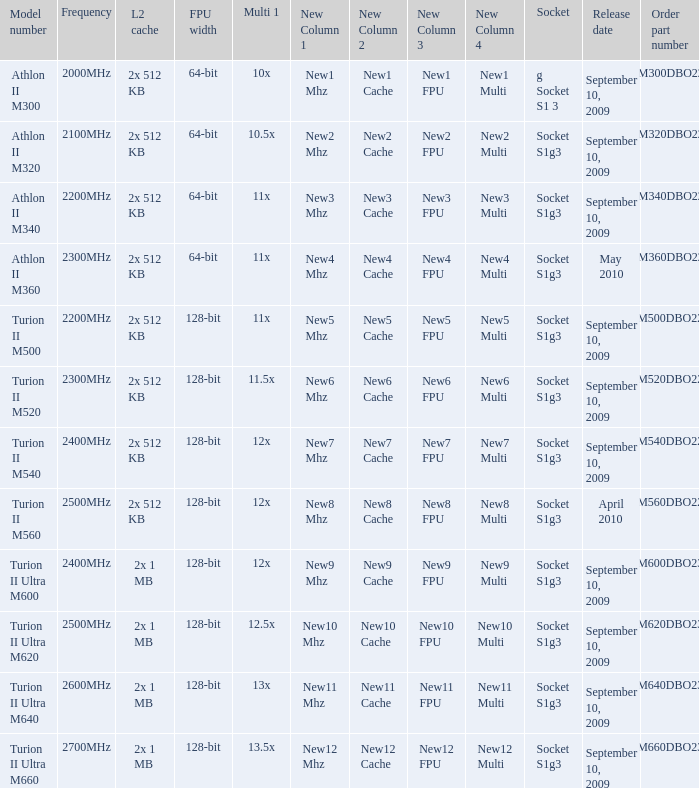What is the L2 cache with a 13.5x multi 1? 2x 1 MB. 